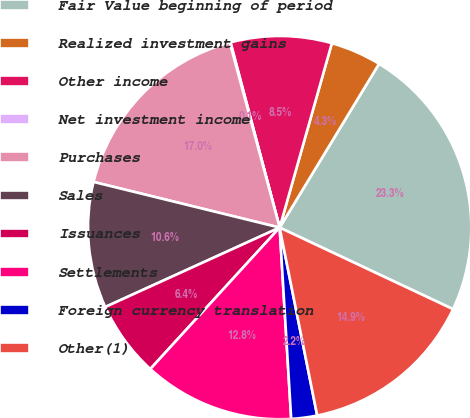Convert chart to OTSL. <chart><loc_0><loc_0><loc_500><loc_500><pie_chart><fcel>Fair Value beginning of period<fcel>Realized investment gains<fcel>Other income<fcel>Net investment income<fcel>Purchases<fcel>Sales<fcel>Issuances<fcel>Settlements<fcel>Foreign currency translation<fcel>Other(1)<nl><fcel>23.32%<fcel>4.29%<fcel>8.52%<fcel>0.06%<fcel>16.98%<fcel>10.63%<fcel>6.41%<fcel>12.75%<fcel>2.18%<fcel>14.86%<nl></chart> 